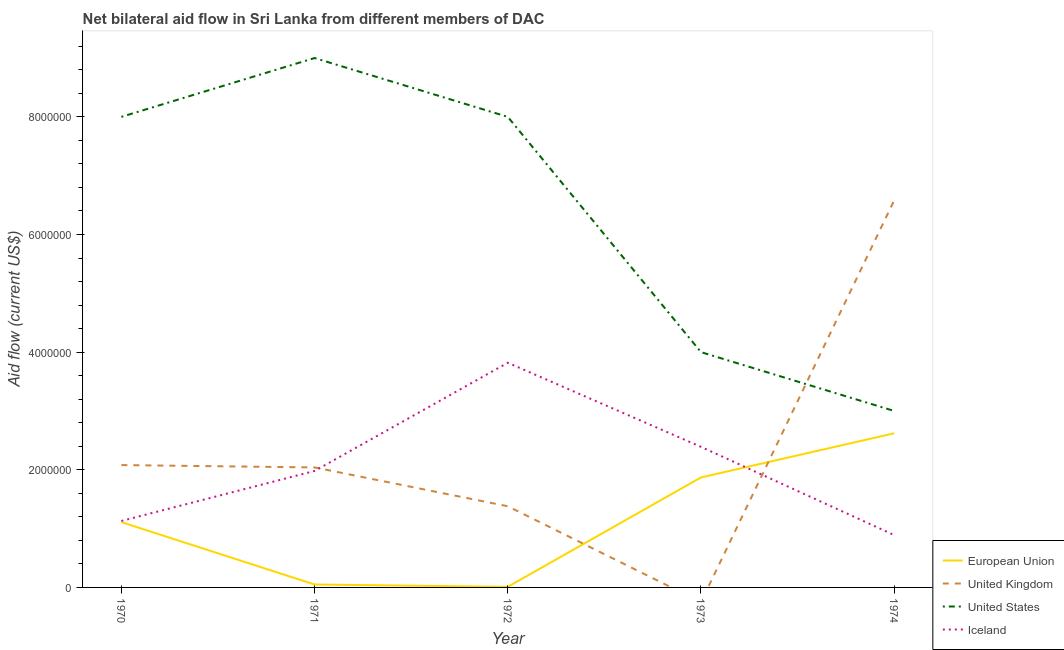How many different coloured lines are there?
Provide a short and direct response. 4. Is the number of lines equal to the number of legend labels?
Offer a terse response. No. What is the amount of aid given by uk in 1973?
Your response must be concise. 0. Across all years, what is the maximum amount of aid given by iceland?
Your answer should be compact. 3.82e+06. Across all years, what is the minimum amount of aid given by eu?
Provide a succinct answer. 10000. In which year was the amount of aid given by eu maximum?
Ensure brevity in your answer.  1974. What is the total amount of aid given by uk in the graph?
Your response must be concise. 1.21e+07. What is the difference between the amount of aid given by uk in 1972 and that in 1974?
Provide a succinct answer. -5.20e+06. What is the difference between the amount of aid given by iceland in 1971 and the amount of aid given by us in 1970?
Give a very brief answer. -6.02e+06. What is the average amount of aid given by us per year?
Offer a very short reply. 6.40e+06. In the year 1974, what is the difference between the amount of aid given by uk and amount of aid given by iceland?
Your answer should be compact. 5.69e+06. Is the amount of aid given by us in 1971 less than that in 1973?
Make the answer very short. No. What is the difference between the highest and the second highest amount of aid given by us?
Offer a very short reply. 1.00e+06. What is the difference between the highest and the lowest amount of aid given by uk?
Your response must be concise. 6.58e+06. In how many years, is the amount of aid given by iceland greater than the average amount of aid given by iceland taken over all years?
Offer a terse response. 2. Is the sum of the amount of aid given by uk in 1970 and 1974 greater than the maximum amount of aid given by us across all years?
Make the answer very short. No. Is it the case that in every year, the sum of the amount of aid given by eu and amount of aid given by uk is greater than the amount of aid given by us?
Provide a succinct answer. No. Does the amount of aid given by us monotonically increase over the years?
Your response must be concise. No. Is the amount of aid given by uk strictly less than the amount of aid given by us over the years?
Keep it short and to the point. No. How many lines are there?
Offer a very short reply. 4. How many years are there in the graph?
Your response must be concise. 5. What is the difference between two consecutive major ticks on the Y-axis?
Provide a short and direct response. 2.00e+06. Where does the legend appear in the graph?
Your response must be concise. Bottom right. How many legend labels are there?
Keep it short and to the point. 4. How are the legend labels stacked?
Provide a succinct answer. Vertical. What is the title of the graph?
Provide a succinct answer. Net bilateral aid flow in Sri Lanka from different members of DAC. Does "Source data assessment" appear as one of the legend labels in the graph?
Make the answer very short. No. What is the label or title of the X-axis?
Offer a terse response. Year. What is the Aid flow (current US$) in European Union in 1970?
Provide a short and direct response. 1.11e+06. What is the Aid flow (current US$) in United Kingdom in 1970?
Keep it short and to the point. 2.08e+06. What is the Aid flow (current US$) of United States in 1970?
Keep it short and to the point. 8.00e+06. What is the Aid flow (current US$) in Iceland in 1970?
Give a very brief answer. 1.13e+06. What is the Aid flow (current US$) of United Kingdom in 1971?
Give a very brief answer. 2.04e+06. What is the Aid flow (current US$) of United States in 1971?
Keep it short and to the point. 9.00e+06. What is the Aid flow (current US$) of Iceland in 1971?
Provide a succinct answer. 1.98e+06. What is the Aid flow (current US$) in United Kingdom in 1972?
Keep it short and to the point. 1.38e+06. What is the Aid flow (current US$) in Iceland in 1972?
Offer a very short reply. 3.82e+06. What is the Aid flow (current US$) in European Union in 1973?
Offer a terse response. 1.87e+06. What is the Aid flow (current US$) in United Kingdom in 1973?
Give a very brief answer. 0. What is the Aid flow (current US$) in United States in 1973?
Ensure brevity in your answer.  4.00e+06. What is the Aid flow (current US$) in Iceland in 1973?
Offer a very short reply. 2.39e+06. What is the Aid flow (current US$) of European Union in 1974?
Your answer should be very brief. 2.62e+06. What is the Aid flow (current US$) in United Kingdom in 1974?
Offer a very short reply. 6.58e+06. What is the Aid flow (current US$) in Iceland in 1974?
Your response must be concise. 8.90e+05. Across all years, what is the maximum Aid flow (current US$) in European Union?
Offer a very short reply. 2.62e+06. Across all years, what is the maximum Aid flow (current US$) in United Kingdom?
Give a very brief answer. 6.58e+06. Across all years, what is the maximum Aid flow (current US$) of United States?
Provide a succinct answer. 9.00e+06. Across all years, what is the maximum Aid flow (current US$) of Iceland?
Make the answer very short. 3.82e+06. Across all years, what is the minimum Aid flow (current US$) of European Union?
Your response must be concise. 10000. Across all years, what is the minimum Aid flow (current US$) in United Kingdom?
Keep it short and to the point. 0. Across all years, what is the minimum Aid flow (current US$) in United States?
Ensure brevity in your answer.  3.00e+06. Across all years, what is the minimum Aid flow (current US$) of Iceland?
Ensure brevity in your answer.  8.90e+05. What is the total Aid flow (current US$) in European Union in the graph?
Give a very brief answer. 5.66e+06. What is the total Aid flow (current US$) in United Kingdom in the graph?
Make the answer very short. 1.21e+07. What is the total Aid flow (current US$) of United States in the graph?
Make the answer very short. 3.20e+07. What is the total Aid flow (current US$) of Iceland in the graph?
Make the answer very short. 1.02e+07. What is the difference between the Aid flow (current US$) in European Union in 1970 and that in 1971?
Your answer should be very brief. 1.06e+06. What is the difference between the Aid flow (current US$) of Iceland in 1970 and that in 1971?
Offer a very short reply. -8.50e+05. What is the difference between the Aid flow (current US$) of European Union in 1970 and that in 1972?
Your answer should be very brief. 1.10e+06. What is the difference between the Aid flow (current US$) of United Kingdom in 1970 and that in 1972?
Your response must be concise. 7.00e+05. What is the difference between the Aid flow (current US$) in Iceland in 1970 and that in 1972?
Offer a terse response. -2.69e+06. What is the difference between the Aid flow (current US$) in European Union in 1970 and that in 1973?
Offer a very short reply. -7.60e+05. What is the difference between the Aid flow (current US$) of Iceland in 1970 and that in 1973?
Ensure brevity in your answer.  -1.26e+06. What is the difference between the Aid flow (current US$) of European Union in 1970 and that in 1974?
Ensure brevity in your answer.  -1.51e+06. What is the difference between the Aid flow (current US$) of United Kingdom in 1970 and that in 1974?
Provide a short and direct response. -4.50e+06. What is the difference between the Aid flow (current US$) of United Kingdom in 1971 and that in 1972?
Your response must be concise. 6.60e+05. What is the difference between the Aid flow (current US$) in Iceland in 1971 and that in 1972?
Offer a very short reply. -1.84e+06. What is the difference between the Aid flow (current US$) in European Union in 1971 and that in 1973?
Ensure brevity in your answer.  -1.82e+06. What is the difference between the Aid flow (current US$) of United States in 1971 and that in 1973?
Keep it short and to the point. 5.00e+06. What is the difference between the Aid flow (current US$) in Iceland in 1971 and that in 1973?
Make the answer very short. -4.10e+05. What is the difference between the Aid flow (current US$) of European Union in 1971 and that in 1974?
Your response must be concise. -2.57e+06. What is the difference between the Aid flow (current US$) in United Kingdom in 1971 and that in 1974?
Offer a terse response. -4.54e+06. What is the difference between the Aid flow (current US$) in United States in 1971 and that in 1974?
Offer a very short reply. 6.00e+06. What is the difference between the Aid flow (current US$) in Iceland in 1971 and that in 1974?
Your response must be concise. 1.09e+06. What is the difference between the Aid flow (current US$) in European Union in 1972 and that in 1973?
Your response must be concise. -1.86e+06. What is the difference between the Aid flow (current US$) of United States in 1972 and that in 1973?
Offer a very short reply. 4.00e+06. What is the difference between the Aid flow (current US$) in Iceland in 1972 and that in 1973?
Provide a short and direct response. 1.43e+06. What is the difference between the Aid flow (current US$) in European Union in 1972 and that in 1974?
Your answer should be compact. -2.61e+06. What is the difference between the Aid flow (current US$) of United Kingdom in 1972 and that in 1974?
Provide a succinct answer. -5.20e+06. What is the difference between the Aid flow (current US$) of Iceland in 1972 and that in 1974?
Make the answer very short. 2.93e+06. What is the difference between the Aid flow (current US$) in European Union in 1973 and that in 1974?
Your answer should be compact. -7.50e+05. What is the difference between the Aid flow (current US$) of Iceland in 1973 and that in 1974?
Provide a succinct answer. 1.50e+06. What is the difference between the Aid flow (current US$) in European Union in 1970 and the Aid flow (current US$) in United Kingdom in 1971?
Your answer should be very brief. -9.30e+05. What is the difference between the Aid flow (current US$) in European Union in 1970 and the Aid flow (current US$) in United States in 1971?
Ensure brevity in your answer.  -7.89e+06. What is the difference between the Aid flow (current US$) of European Union in 1970 and the Aid flow (current US$) of Iceland in 1971?
Provide a succinct answer. -8.70e+05. What is the difference between the Aid flow (current US$) in United Kingdom in 1970 and the Aid flow (current US$) in United States in 1971?
Your response must be concise. -6.92e+06. What is the difference between the Aid flow (current US$) in United Kingdom in 1970 and the Aid flow (current US$) in Iceland in 1971?
Give a very brief answer. 1.00e+05. What is the difference between the Aid flow (current US$) in United States in 1970 and the Aid flow (current US$) in Iceland in 1971?
Offer a terse response. 6.02e+06. What is the difference between the Aid flow (current US$) of European Union in 1970 and the Aid flow (current US$) of United States in 1972?
Provide a succinct answer. -6.89e+06. What is the difference between the Aid flow (current US$) of European Union in 1970 and the Aid flow (current US$) of Iceland in 1972?
Give a very brief answer. -2.71e+06. What is the difference between the Aid flow (current US$) in United Kingdom in 1970 and the Aid flow (current US$) in United States in 1972?
Offer a very short reply. -5.92e+06. What is the difference between the Aid flow (current US$) of United Kingdom in 1970 and the Aid flow (current US$) of Iceland in 1972?
Make the answer very short. -1.74e+06. What is the difference between the Aid flow (current US$) in United States in 1970 and the Aid flow (current US$) in Iceland in 1972?
Your answer should be very brief. 4.18e+06. What is the difference between the Aid flow (current US$) in European Union in 1970 and the Aid flow (current US$) in United States in 1973?
Provide a succinct answer. -2.89e+06. What is the difference between the Aid flow (current US$) of European Union in 1970 and the Aid flow (current US$) of Iceland in 1973?
Offer a very short reply. -1.28e+06. What is the difference between the Aid flow (current US$) in United Kingdom in 1970 and the Aid flow (current US$) in United States in 1973?
Provide a short and direct response. -1.92e+06. What is the difference between the Aid flow (current US$) in United Kingdom in 1970 and the Aid flow (current US$) in Iceland in 1973?
Make the answer very short. -3.10e+05. What is the difference between the Aid flow (current US$) of United States in 1970 and the Aid flow (current US$) of Iceland in 1973?
Offer a terse response. 5.61e+06. What is the difference between the Aid flow (current US$) in European Union in 1970 and the Aid flow (current US$) in United Kingdom in 1974?
Your response must be concise. -5.47e+06. What is the difference between the Aid flow (current US$) in European Union in 1970 and the Aid flow (current US$) in United States in 1974?
Make the answer very short. -1.89e+06. What is the difference between the Aid flow (current US$) of European Union in 1970 and the Aid flow (current US$) of Iceland in 1974?
Keep it short and to the point. 2.20e+05. What is the difference between the Aid flow (current US$) of United Kingdom in 1970 and the Aid flow (current US$) of United States in 1974?
Your answer should be compact. -9.20e+05. What is the difference between the Aid flow (current US$) of United Kingdom in 1970 and the Aid flow (current US$) of Iceland in 1974?
Provide a short and direct response. 1.19e+06. What is the difference between the Aid flow (current US$) in United States in 1970 and the Aid flow (current US$) in Iceland in 1974?
Your answer should be compact. 7.11e+06. What is the difference between the Aid flow (current US$) in European Union in 1971 and the Aid flow (current US$) in United Kingdom in 1972?
Keep it short and to the point. -1.33e+06. What is the difference between the Aid flow (current US$) of European Union in 1971 and the Aid flow (current US$) of United States in 1972?
Give a very brief answer. -7.95e+06. What is the difference between the Aid flow (current US$) in European Union in 1971 and the Aid flow (current US$) in Iceland in 1972?
Offer a very short reply. -3.77e+06. What is the difference between the Aid flow (current US$) of United Kingdom in 1971 and the Aid flow (current US$) of United States in 1972?
Offer a very short reply. -5.96e+06. What is the difference between the Aid flow (current US$) of United Kingdom in 1971 and the Aid flow (current US$) of Iceland in 1972?
Give a very brief answer. -1.78e+06. What is the difference between the Aid flow (current US$) in United States in 1971 and the Aid flow (current US$) in Iceland in 1972?
Your response must be concise. 5.18e+06. What is the difference between the Aid flow (current US$) in European Union in 1971 and the Aid flow (current US$) in United States in 1973?
Keep it short and to the point. -3.95e+06. What is the difference between the Aid flow (current US$) in European Union in 1971 and the Aid flow (current US$) in Iceland in 1973?
Provide a succinct answer. -2.34e+06. What is the difference between the Aid flow (current US$) of United Kingdom in 1971 and the Aid flow (current US$) of United States in 1973?
Provide a succinct answer. -1.96e+06. What is the difference between the Aid flow (current US$) in United Kingdom in 1971 and the Aid flow (current US$) in Iceland in 1973?
Your answer should be very brief. -3.50e+05. What is the difference between the Aid flow (current US$) of United States in 1971 and the Aid flow (current US$) of Iceland in 1973?
Offer a very short reply. 6.61e+06. What is the difference between the Aid flow (current US$) in European Union in 1971 and the Aid flow (current US$) in United Kingdom in 1974?
Provide a succinct answer. -6.53e+06. What is the difference between the Aid flow (current US$) in European Union in 1971 and the Aid flow (current US$) in United States in 1974?
Your answer should be very brief. -2.95e+06. What is the difference between the Aid flow (current US$) of European Union in 1971 and the Aid flow (current US$) of Iceland in 1974?
Make the answer very short. -8.40e+05. What is the difference between the Aid flow (current US$) of United Kingdom in 1971 and the Aid flow (current US$) of United States in 1974?
Your answer should be compact. -9.60e+05. What is the difference between the Aid flow (current US$) in United Kingdom in 1971 and the Aid flow (current US$) in Iceland in 1974?
Offer a very short reply. 1.15e+06. What is the difference between the Aid flow (current US$) of United States in 1971 and the Aid flow (current US$) of Iceland in 1974?
Your answer should be compact. 8.11e+06. What is the difference between the Aid flow (current US$) in European Union in 1972 and the Aid flow (current US$) in United States in 1973?
Your response must be concise. -3.99e+06. What is the difference between the Aid flow (current US$) in European Union in 1972 and the Aid flow (current US$) in Iceland in 1973?
Offer a very short reply. -2.38e+06. What is the difference between the Aid flow (current US$) in United Kingdom in 1972 and the Aid flow (current US$) in United States in 1973?
Provide a short and direct response. -2.62e+06. What is the difference between the Aid flow (current US$) of United Kingdom in 1972 and the Aid flow (current US$) of Iceland in 1973?
Offer a very short reply. -1.01e+06. What is the difference between the Aid flow (current US$) of United States in 1972 and the Aid flow (current US$) of Iceland in 1973?
Your answer should be compact. 5.61e+06. What is the difference between the Aid flow (current US$) of European Union in 1972 and the Aid flow (current US$) of United Kingdom in 1974?
Your answer should be very brief. -6.57e+06. What is the difference between the Aid flow (current US$) in European Union in 1972 and the Aid flow (current US$) in United States in 1974?
Make the answer very short. -2.99e+06. What is the difference between the Aid flow (current US$) of European Union in 1972 and the Aid flow (current US$) of Iceland in 1974?
Make the answer very short. -8.80e+05. What is the difference between the Aid flow (current US$) in United Kingdom in 1972 and the Aid flow (current US$) in United States in 1974?
Offer a terse response. -1.62e+06. What is the difference between the Aid flow (current US$) in United States in 1972 and the Aid flow (current US$) in Iceland in 1974?
Make the answer very short. 7.11e+06. What is the difference between the Aid flow (current US$) in European Union in 1973 and the Aid flow (current US$) in United Kingdom in 1974?
Offer a terse response. -4.71e+06. What is the difference between the Aid flow (current US$) of European Union in 1973 and the Aid flow (current US$) of United States in 1974?
Your response must be concise. -1.13e+06. What is the difference between the Aid flow (current US$) of European Union in 1973 and the Aid flow (current US$) of Iceland in 1974?
Provide a short and direct response. 9.80e+05. What is the difference between the Aid flow (current US$) of United States in 1973 and the Aid flow (current US$) of Iceland in 1974?
Provide a succinct answer. 3.11e+06. What is the average Aid flow (current US$) of European Union per year?
Your response must be concise. 1.13e+06. What is the average Aid flow (current US$) in United Kingdom per year?
Offer a very short reply. 2.42e+06. What is the average Aid flow (current US$) in United States per year?
Offer a terse response. 6.40e+06. What is the average Aid flow (current US$) of Iceland per year?
Offer a terse response. 2.04e+06. In the year 1970, what is the difference between the Aid flow (current US$) of European Union and Aid flow (current US$) of United Kingdom?
Your answer should be very brief. -9.70e+05. In the year 1970, what is the difference between the Aid flow (current US$) in European Union and Aid flow (current US$) in United States?
Keep it short and to the point. -6.89e+06. In the year 1970, what is the difference between the Aid flow (current US$) of European Union and Aid flow (current US$) of Iceland?
Provide a succinct answer. -2.00e+04. In the year 1970, what is the difference between the Aid flow (current US$) of United Kingdom and Aid flow (current US$) of United States?
Make the answer very short. -5.92e+06. In the year 1970, what is the difference between the Aid flow (current US$) in United Kingdom and Aid flow (current US$) in Iceland?
Ensure brevity in your answer.  9.50e+05. In the year 1970, what is the difference between the Aid flow (current US$) in United States and Aid flow (current US$) in Iceland?
Your response must be concise. 6.87e+06. In the year 1971, what is the difference between the Aid flow (current US$) in European Union and Aid flow (current US$) in United Kingdom?
Keep it short and to the point. -1.99e+06. In the year 1971, what is the difference between the Aid flow (current US$) of European Union and Aid flow (current US$) of United States?
Give a very brief answer. -8.95e+06. In the year 1971, what is the difference between the Aid flow (current US$) of European Union and Aid flow (current US$) of Iceland?
Ensure brevity in your answer.  -1.93e+06. In the year 1971, what is the difference between the Aid flow (current US$) of United Kingdom and Aid flow (current US$) of United States?
Ensure brevity in your answer.  -6.96e+06. In the year 1971, what is the difference between the Aid flow (current US$) of United States and Aid flow (current US$) of Iceland?
Provide a short and direct response. 7.02e+06. In the year 1972, what is the difference between the Aid flow (current US$) in European Union and Aid flow (current US$) in United Kingdom?
Offer a terse response. -1.37e+06. In the year 1972, what is the difference between the Aid flow (current US$) in European Union and Aid flow (current US$) in United States?
Provide a short and direct response. -7.99e+06. In the year 1972, what is the difference between the Aid flow (current US$) of European Union and Aid flow (current US$) of Iceland?
Offer a very short reply. -3.81e+06. In the year 1972, what is the difference between the Aid flow (current US$) in United Kingdom and Aid flow (current US$) in United States?
Provide a short and direct response. -6.62e+06. In the year 1972, what is the difference between the Aid flow (current US$) in United Kingdom and Aid flow (current US$) in Iceland?
Ensure brevity in your answer.  -2.44e+06. In the year 1972, what is the difference between the Aid flow (current US$) of United States and Aid flow (current US$) of Iceland?
Your answer should be compact. 4.18e+06. In the year 1973, what is the difference between the Aid flow (current US$) in European Union and Aid flow (current US$) in United States?
Offer a terse response. -2.13e+06. In the year 1973, what is the difference between the Aid flow (current US$) in European Union and Aid flow (current US$) in Iceland?
Offer a very short reply. -5.20e+05. In the year 1973, what is the difference between the Aid flow (current US$) in United States and Aid flow (current US$) in Iceland?
Make the answer very short. 1.61e+06. In the year 1974, what is the difference between the Aid flow (current US$) in European Union and Aid flow (current US$) in United Kingdom?
Keep it short and to the point. -3.96e+06. In the year 1974, what is the difference between the Aid flow (current US$) in European Union and Aid flow (current US$) in United States?
Your answer should be very brief. -3.80e+05. In the year 1974, what is the difference between the Aid flow (current US$) in European Union and Aid flow (current US$) in Iceland?
Provide a short and direct response. 1.73e+06. In the year 1974, what is the difference between the Aid flow (current US$) in United Kingdom and Aid flow (current US$) in United States?
Make the answer very short. 3.58e+06. In the year 1974, what is the difference between the Aid flow (current US$) in United Kingdom and Aid flow (current US$) in Iceland?
Your answer should be compact. 5.69e+06. In the year 1974, what is the difference between the Aid flow (current US$) of United States and Aid flow (current US$) of Iceland?
Your answer should be compact. 2.11e+06. What is the ratio of the Aid flow (current US$) in United Kingdom in 1970 to that in 1971?
Your answer should be very brief. 1.02. What is the ratio of the Aid flow (current US$) of United States in 1970 to that in 1971?
Provide a short and direct response. 0.89. What is the ratio of the Aid flow (current US$) of Iceland in 1970 to that in 1971?
Keep it short and to the point. 0.57. What is the ratio of the Aid flow (current US$) in European Union in 1970 to that in 1972?
Provide a short and direct response. 111. What is the ratio of the Aid flow (current US$) in United Kingdom in 1970 to that in 1972?
Provide a short and direct response. 1.51. What is the ratio of the Aid flow (current US$) in United States in 1970 to that in 1972?
Ensure brevity in your answer.  1. What is the ratio of the Aid flow (current US$) in Iceland in 1970 to that in 1972?
Make the answer very short. 0.3. What is the ratio of the Aid flow (current US$) in European Union in 1970 to that in 1973?
Make the answer very short. 0.59. What is the ratio of the Aid flow (current US$) in Iceland in 1970 to that in 1973?
Offer a terse response. 0.47. What is the ratio of the Aid flow (current US$) in European Union in 1970 to that in 1974?
Offer a very short reply. 0.42. What is the ratio of the Aid flow (current US$) in United Kingdom in 1970 to that in 1974?
Offer a terse response. 0.32. What is the ratio of the Aid flow (current US$) of United States in 1970 to that in 1974?
Give a very brief answer. 2.67. What is the ratio of the Aid flow (current US$) of Iceland in 1970 to that in 1974?
Keep it short and to the point. 1.27. What is the ratio of the Aid flow (current US$) of United Kingdom in 1971 to that in 1972?
Make the answer very short. 1.48. What is the ratio of the Aid flow (current US$) of Iceland in 1971 to that in 1972?
Make the answer very short. 0.52. What is the ratio of the Aid flow (current US$) of European Union in 1971 to that in 1973?
Your answer should be very brief. 0.03. What is the ratio of the Aid flow (current US$) of United States in 1971 to that in 1973?
Provide a short and direct response. 2.25. What is the ratio of the Aid flow (current US$) in Iceland in 1971 to that in 1973?
Ensure brevity in your answer.  0.83. What is the ratio of the Aid flow (current US$) in European Union in 1971 to that in 1974?
Provide a short and direct response. 0.02. What is the ratio of the Aid flow (current US$) of United Kingdom in 1971 to that in 1974?
Offer a very short reply. 0.31. What is the ratio of the Aid flow (current US$) in United States in 1971 to that in 1974?
Ensure brevity in your answer.  3. What is the ratio of the Aid flow (current US$) in Iceland in 1971 to that in 1974?
Your response must be concise. 2.22. What is the ratio of the Aid flow (current US$) of European Union in 1972 to that in 1973?
Give a very brief answer. 0.01. What is the ratio of the Aid flow (current US$) of United States in 1972 to that in 1973?
Offer a terse response. 2. What is the ratio of the Aid flow (current US$) in Iceland in 1972 to that in 1973?
Make the answer very short. 1.6. What is the ratio of the Aid flow (current US$) of European Union in 1972 to that in 1974?
Provide a succinct answer. 0. What is the ratio of the Aid flow (current US$) of United Kingdom in 1972 to that in 1974?
Offer a terse response. 0.21. What is the ratio of the Aid flow (current US$) of United States in 1972 to that in 1974?
Offer a very short reply. 2.67. What is the ratio of the Aid flow (current US$) in Iceland in 1972 to that in 1974?
Keep it short and to the point. 4.29. What is the ratio of the Aid flow (current US$) in European Union in 1973 to that in 1974?
Your answer should be very brief. 0.71. What is the ratio of the Aid flow (current US$) in Iceland in 1973 to that in 1974?
Your response must be concise. 2.69. What is the difference between the highest and the second highest Aid flow (current US$) in European Union?
Provide a short and direct response. 7.50e+05. What is the difference between the highest and the second highest Aid flow (current US$) of United Kingdom?
Keep it short and to the point. 4.50e+06. What is the difference between the highest and the second highest Aid flow (current US$) in United States?
Your answer should be very brief. 1.00e+06. What is the difference between the highest and the second highest Aid flow (current US$) of Iceland?
Your answer should be compact. 1.43e+06. What is the difference between the highest and the lowest Aid flow (current US$) of European Union?
Offer a very short reply. 2.61e+06. What is the difference between the highest and the lowest Aid flow (current US$) in United Kingdom?
Provide a succinct answer. 6.58e+06. What is the difference between the highest and the lowest Aid flow (current US$) in Iceland?
Your answer should be very brief. 2.93e+06. 